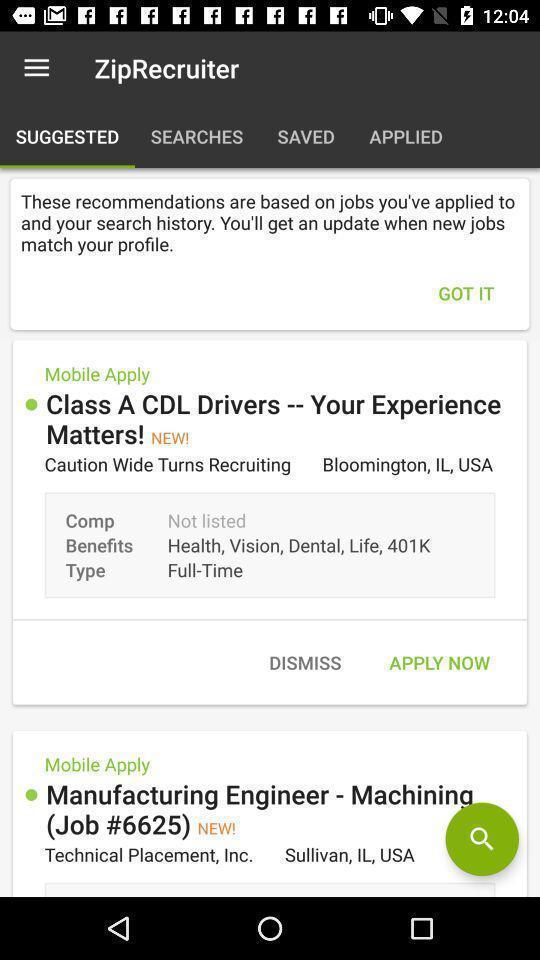What can you discern from this picture? Screen showing suggested page in a job search app. 